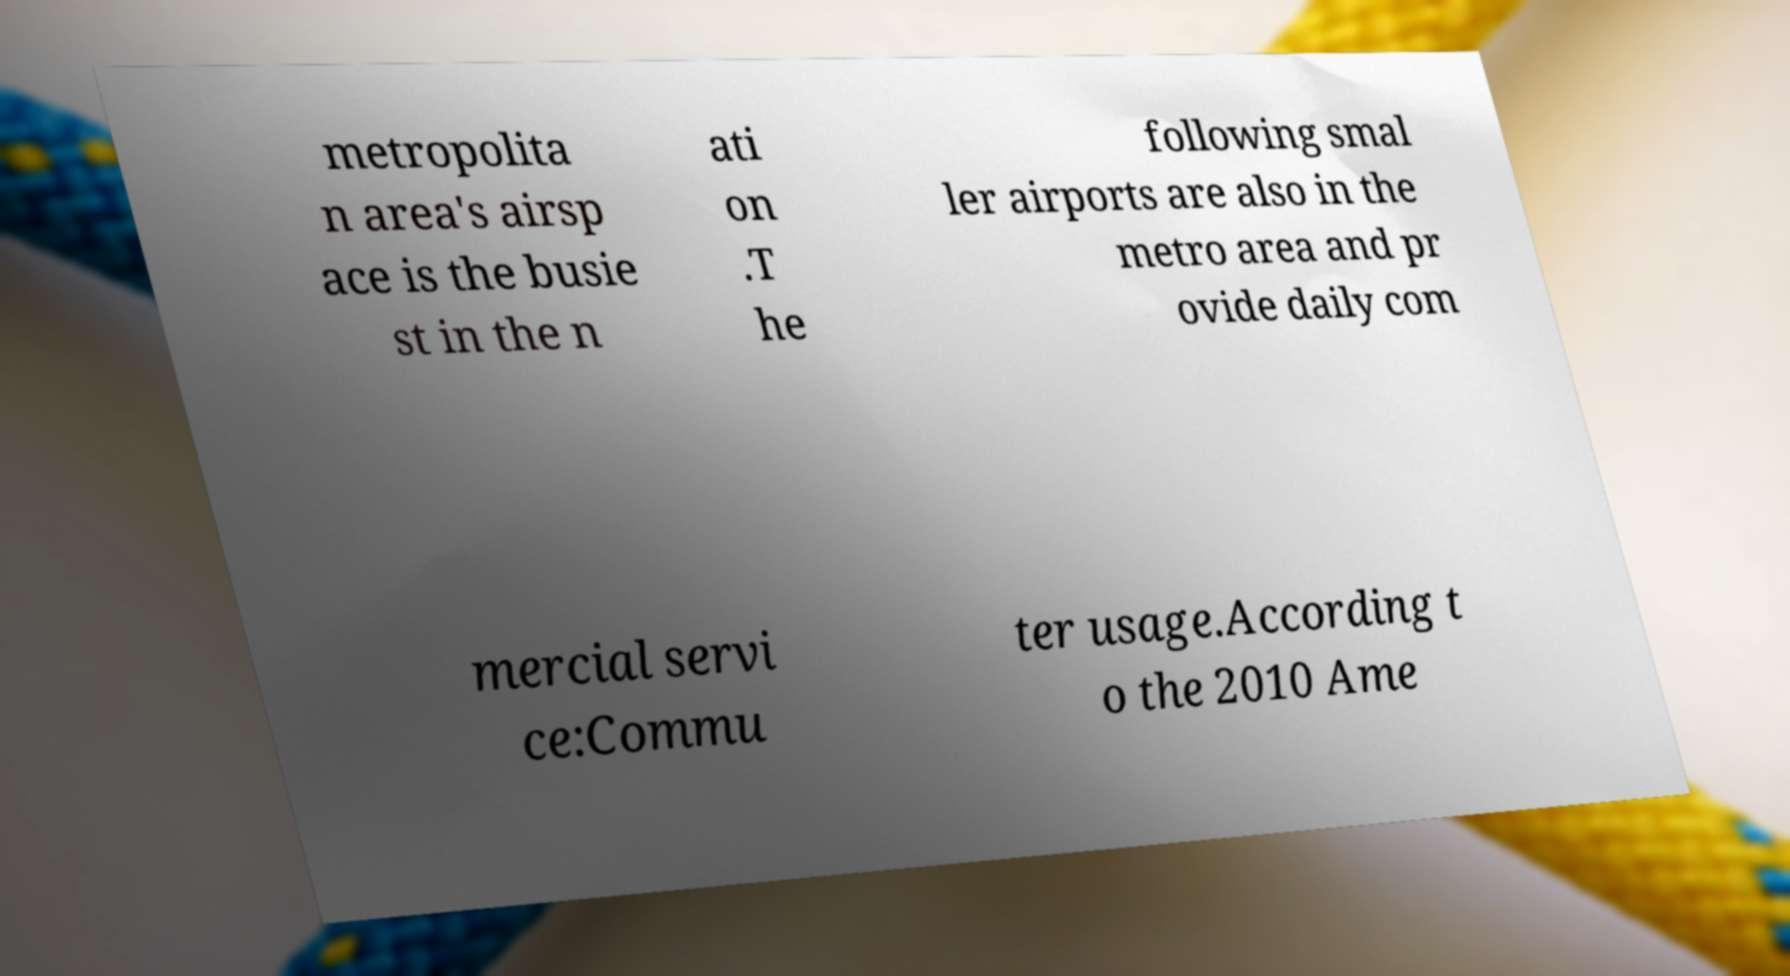I need the written content from this picture converted into text. Can you do that? metropolita n area's airsp ace is the busie st in the n ati on .T he following smal ler airports are also in the metro area and pr ovide daily com mercial servi ce:Commu ter usage.According t o the 2010 Ame 